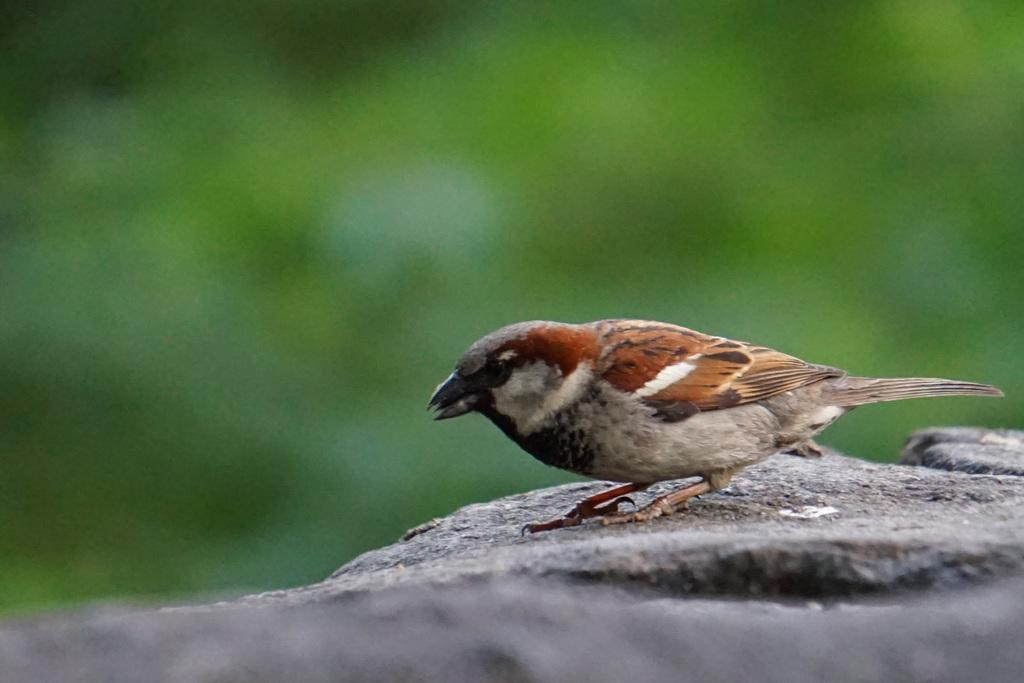What type of animal is present in the image? There is a bird in the image. Where is the bird located? The bird is on an object that resembles a rock. Can you describe the background of the image? The background of the image is blurred. How does the girl tend to her wound in the image? There is no girl or wound present in the image; it features a bird on an object that resembles a rock with a blurred background. 